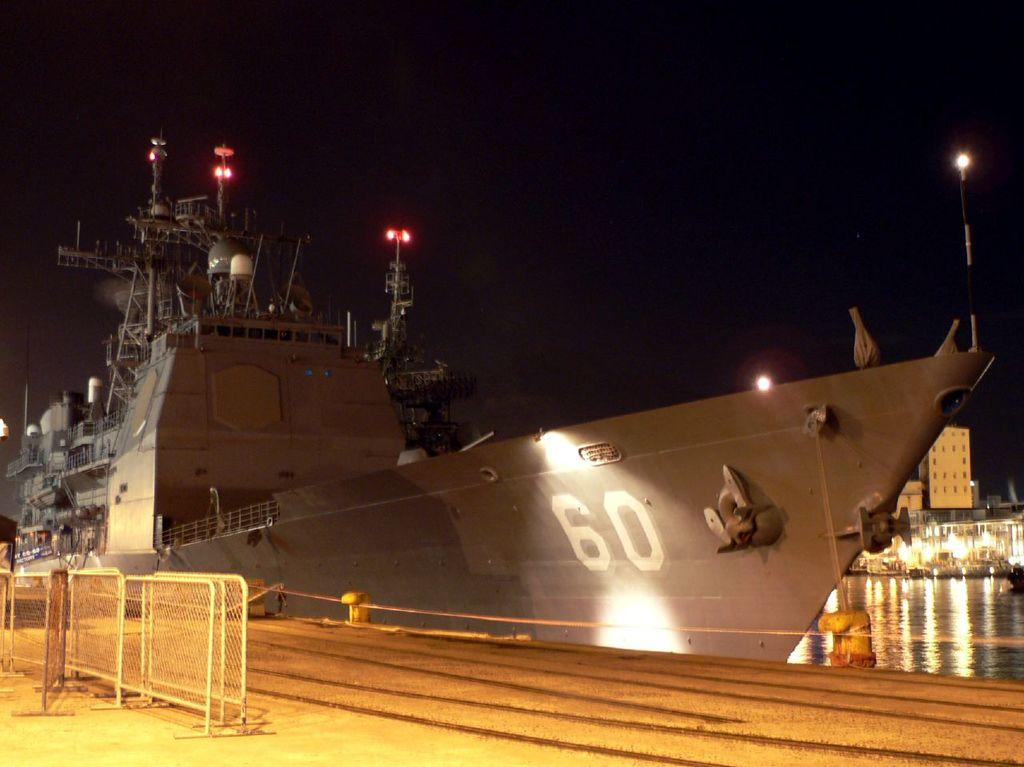<image>
Create a compact narrative representing the image presented. A large ship numbered 60 is docked at night. 